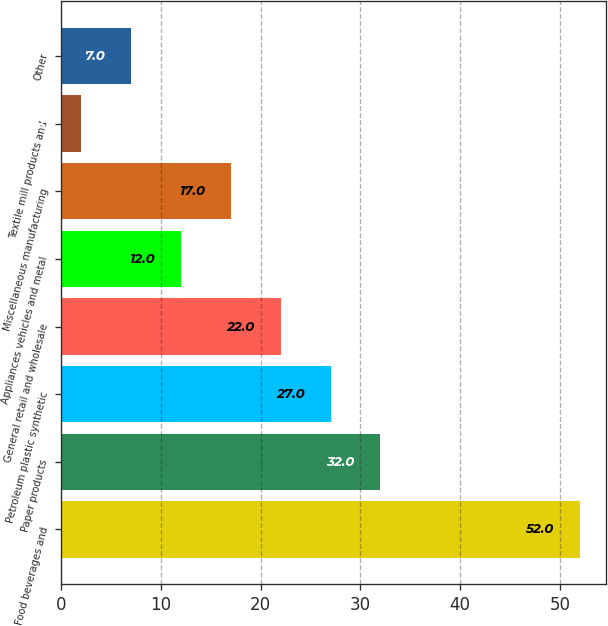Convert chart to OTSL. <chart><loc_0><loc_0><loc_500><loc_500><bar_chart><fcel>Food beverages and<fcel>Paper products<fcel>Petroleum plastic synthetic<fcel>General retail and wholesale<fcel>Appliances vehicles and metal<fcel>Miscellaneous manufacturing<fcel>Textile mill products and<fcel>Other<nl><fcel>52<fcel>32<fcel>27<fcel>22<fcel>12<fcel>17<fcel>2<fcel>7<nl></chart> 